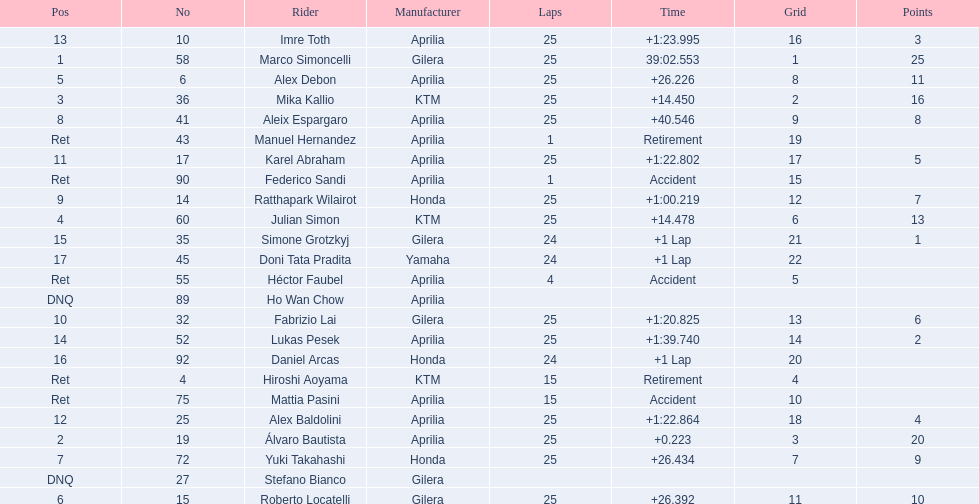How many laps did hiroshi aoyama perform? 15. How many laps did marco simoncelli perform? 25. Who performed more laps out of hiroshi aoyama and marco 
simoncelli? Marco Simoncelli. 